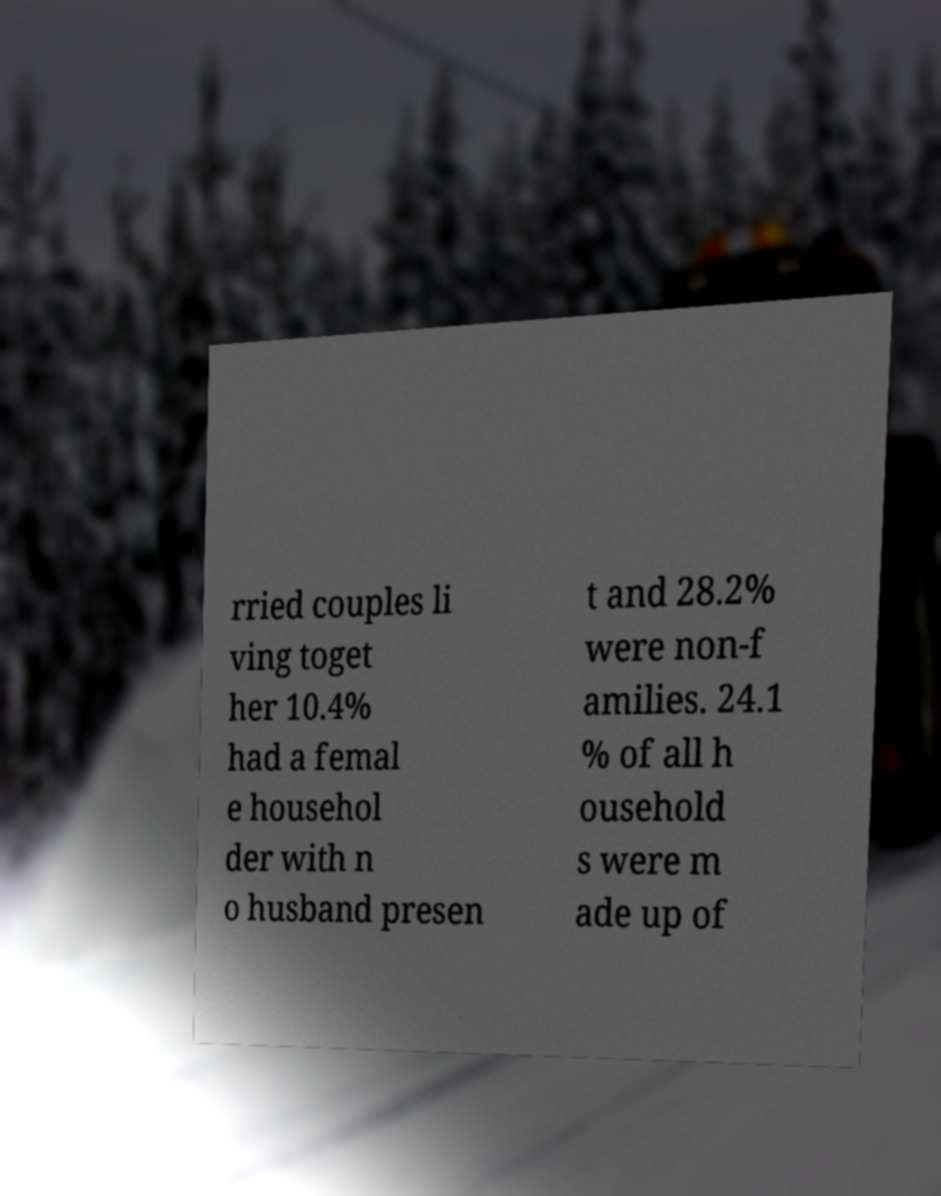Please read and relay the text visible in this image. What does it say? rried couples li ving toget her 10.4% had a femal e househol der with n o husband presen t and 28.2% were non-f amilies. 24.1 % of all h ousehold s were m ade up of 